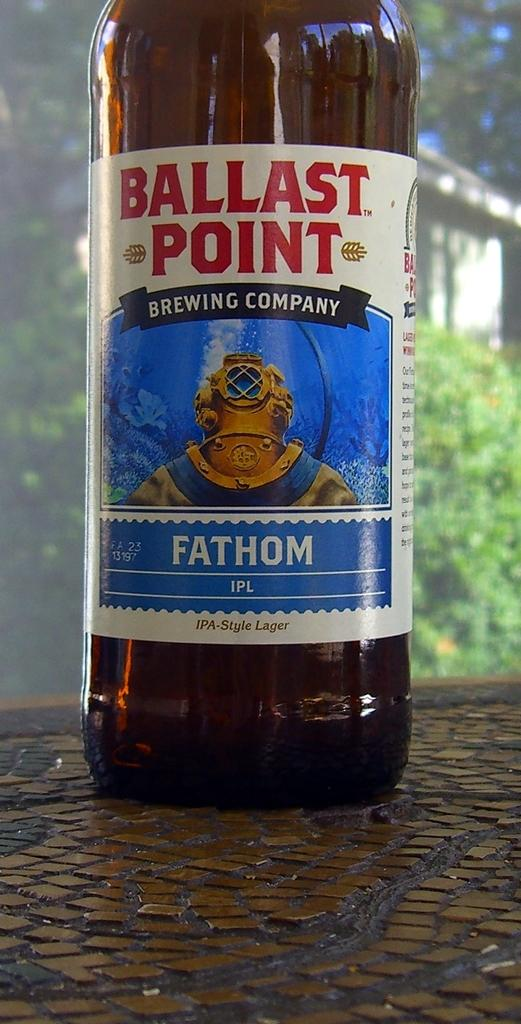<image>
Relay a brief, clear account of the picture shown. A bottle of Ballast Point sits on top of a table. 